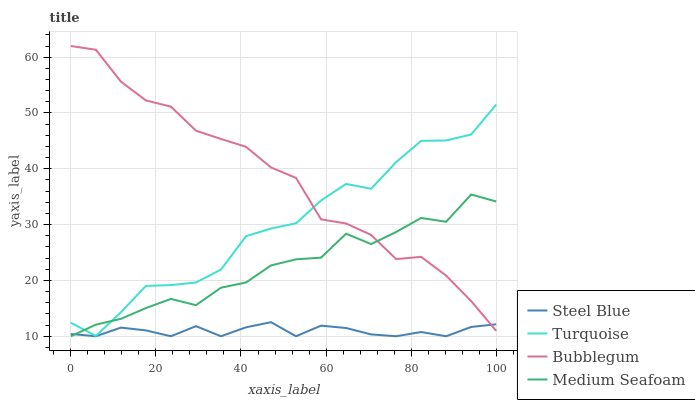Does Steel Blue have the minimum area under the curve?
Answer yes or no. Yes. Does Bubblegum have the maximum area under the curve?
Answer yes or no. Yes. Does Bubblegum have the minimum area under the curve?
Answer yes or no. No. Does Steel Blue have the maximum area under the curve?
Answer yes or no. No. Is Steel Blue the smoothest?
Answer yes or no. Yes. Is Turquoise the roughest?
Answer yes or no. Yes. Is Bubblegum the smoothest?
Answer yes or no. No. Is Bubblegum the roughest?
Answer yes or no. No. Does Steel Blue have the lowest value?
Answer yes or no. Yes. Does Bubblegum have the lowest value?
Answer yes or no. No. Does Bubblegum have the highest value?
Answer yes or no. Yes. Does Steel Blue have the highest value?
Answer yes or no. No. Is Steel Blue less than Turquoise?
Answer yes or no. Yes. Is Turquoise greater than Steel Blue?
Answer yes or no. Yes. Does Turquoise intersect Medium Seafoam?
Answer yes or no. Yes. Is Turquoise less than Medium Seafoam?
Answer yes or no. No. Is Turquoise greater than Medium Seafoam?
Answer yes or no. No. Does Steel Blue intersect Turquoise?
Answer yes or no. No. 